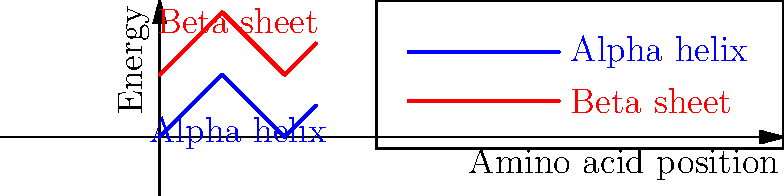Based on the energy profiles shown in the graph, which secondary structure (alpha helix or beta sheet) is more likely to form in this protein segment, and why? To determine which secondary structure is more likely to form, we need to analyze the energy profiles for both the alpha helix and beta sheet:

1. Observe the energy levels:
   - The blue line represents the alpha helix energy profile.
   - The red line represents the beta sheet energy profile.

2. Compare the overall energy levels:
   - The alpha helix profile (blue) shows lower energy values, ranging from 0 to 2.
   - The beta sheet profile (red) shows higher energy values, ranging from 2 to 4.

3. Understand the relationship between energy and stability:
   - Lower energy states are generally more stable in protein structures.
   - Proteins tend to fold into conformations that minimize their free energy.

4. Apply the principle of minimum energy:
   - The alpha helix has a lower energy profile throughout the segment.
   - This indicates that the alpha helix conformation would be more stable for this protein segment.

5. Consider the energy difference:
   - The energy difference between the two profiles is consistent, with the alpha helix always having lower energy.
   - This suggests a strong preference for the alpha helix structure across the entire segment.

Therefore, based on the energy profiles, the alpha helix secondary structure is more likely to form in this protein segment because it consistently exhibits lower energy levels, indicating greater stability compared to the beta sheet structure.
Answer: Alpha helix, due to its lower energy profile indicating greater stability. 